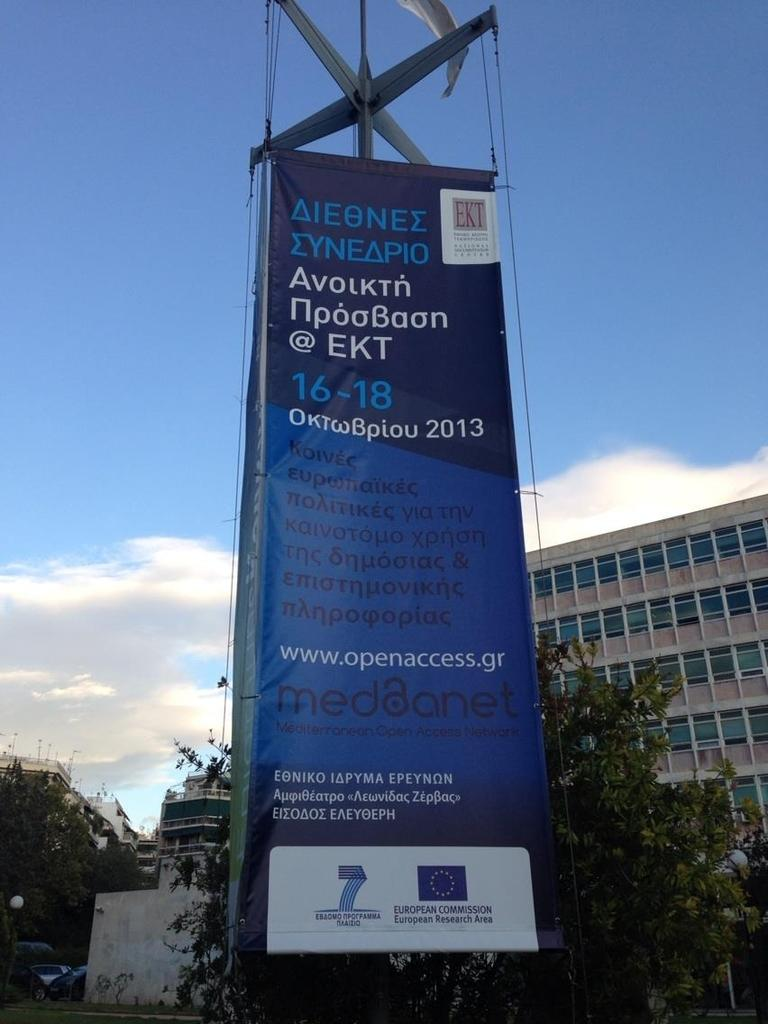<image>
Offer a succinct explanation of the picture presented. An advertisement that shows a link to www.openaccess.gr 